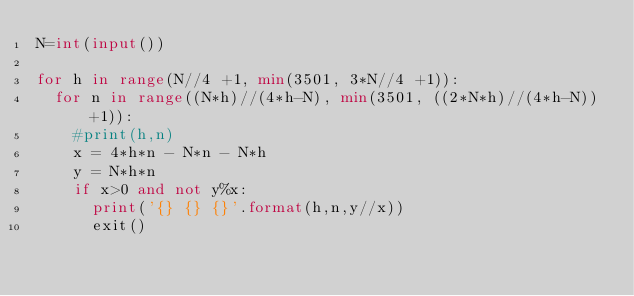<code> <loc_0><loc_0><loc_500><loc_500><_Python_>N=int(input())

for h in range(N//4 +1, min(3501, 3*N//4 +1)):
  for n in range((N*h)//(4*h-N), min(3501, ((2*N*h)//(4*h-N))+1)):
    #print(h,n)
    x = 4*h*n - N*n - N*h
    y = N*h*n
    if x>0 and not y%x:
      print('{} {} {}'.format(h,n,y//x))
      exit()
</code> 